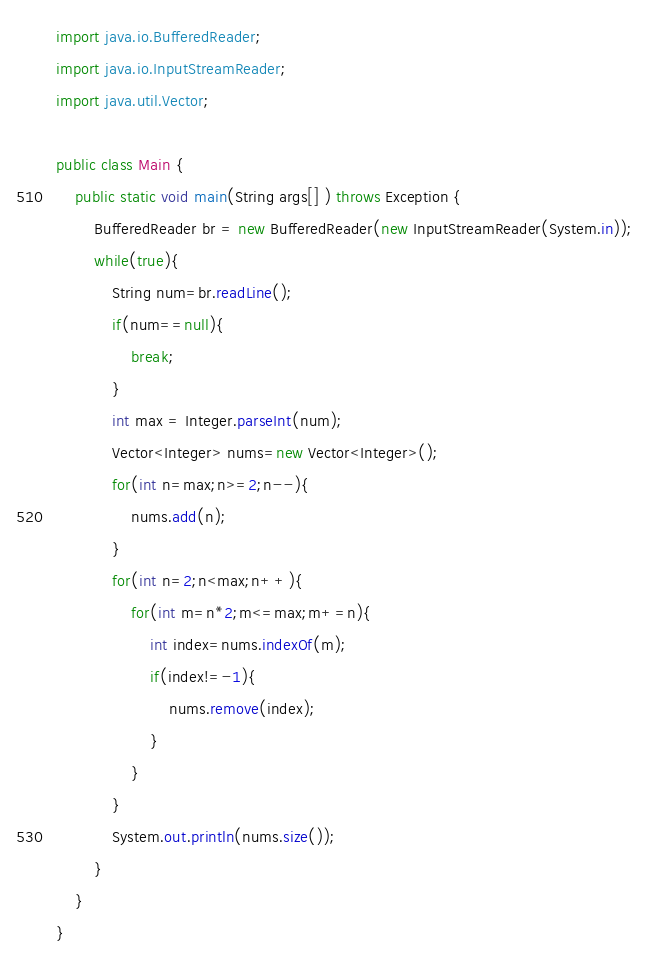Convert code to text. <code><loc_0><loc_0><loc_500><loc_500><_Java_>import java.io.BufferedReader;
import java.io.InputStreamReader;
import java.util.Vector;

public class Main {
	public static void main(String args[] ) throws Exception {
		BufferedReader br = new BufferedReader(new InputStreamReader(System.in));
		while(true){
			String num=br.readLine();
			if(num==null){
				break;
			}
			int max = Integer.parseInt(num);
			Vector<Integer> nums=new Vector<Integer>();
			for(int n=max;n>=2;n--){
				nums.add(n);
			}
			for(int n=2;n<max;n++){
				for(int m=n*2;m<=max;m+=n){
					int index=nums.indexOf(m);
					if(index!=-1){
						nums.remove(index);
					}
				}
			}
			System.out.println(nums.size());
		}
	}
}</code> 